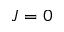<formula> <loc_0><loc_0><loc_500><loc_500>J = 0</formula> 